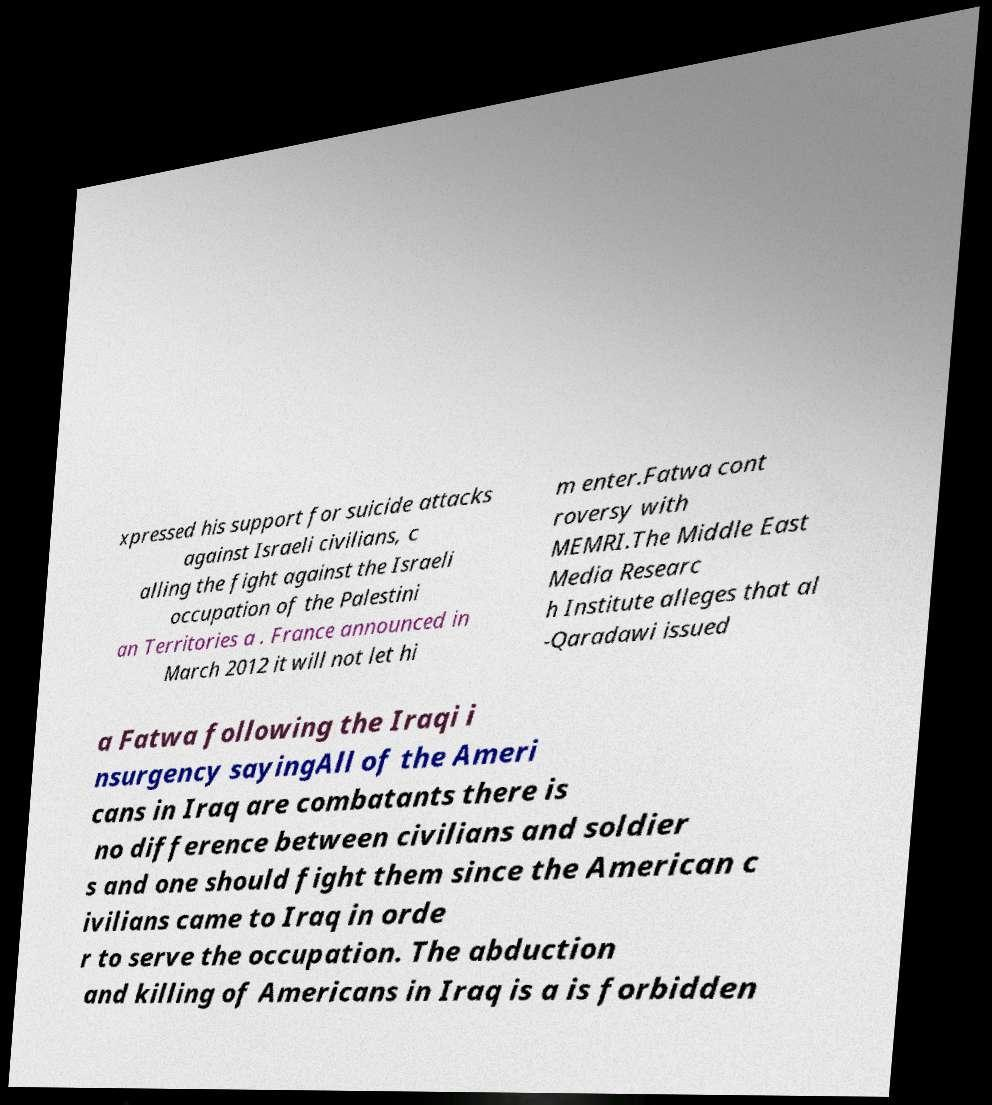I need the written content from this picture converted into text. Can you do that? xpressed his support for suicide attacks against Israeli civilians, c alling the fight against the Israeli occupation of the Palestini an Territories a . France announced in March 2012 it will not let hi m enter.Fatwa cont roversy with MEMRI.The Middle East Media Researc h Institute alleges that al -Qaradawi issued a Fatwa following the Iraqi i nsurgency sayingAll of the Ameri cans in Iraq are combatants there is no difference between civilians and soldier s and one should fight them since the American c ivilians came to Iraq in orde r to serve the occupation. The abduction and killing of Americans in Iraq is a is forbidden 